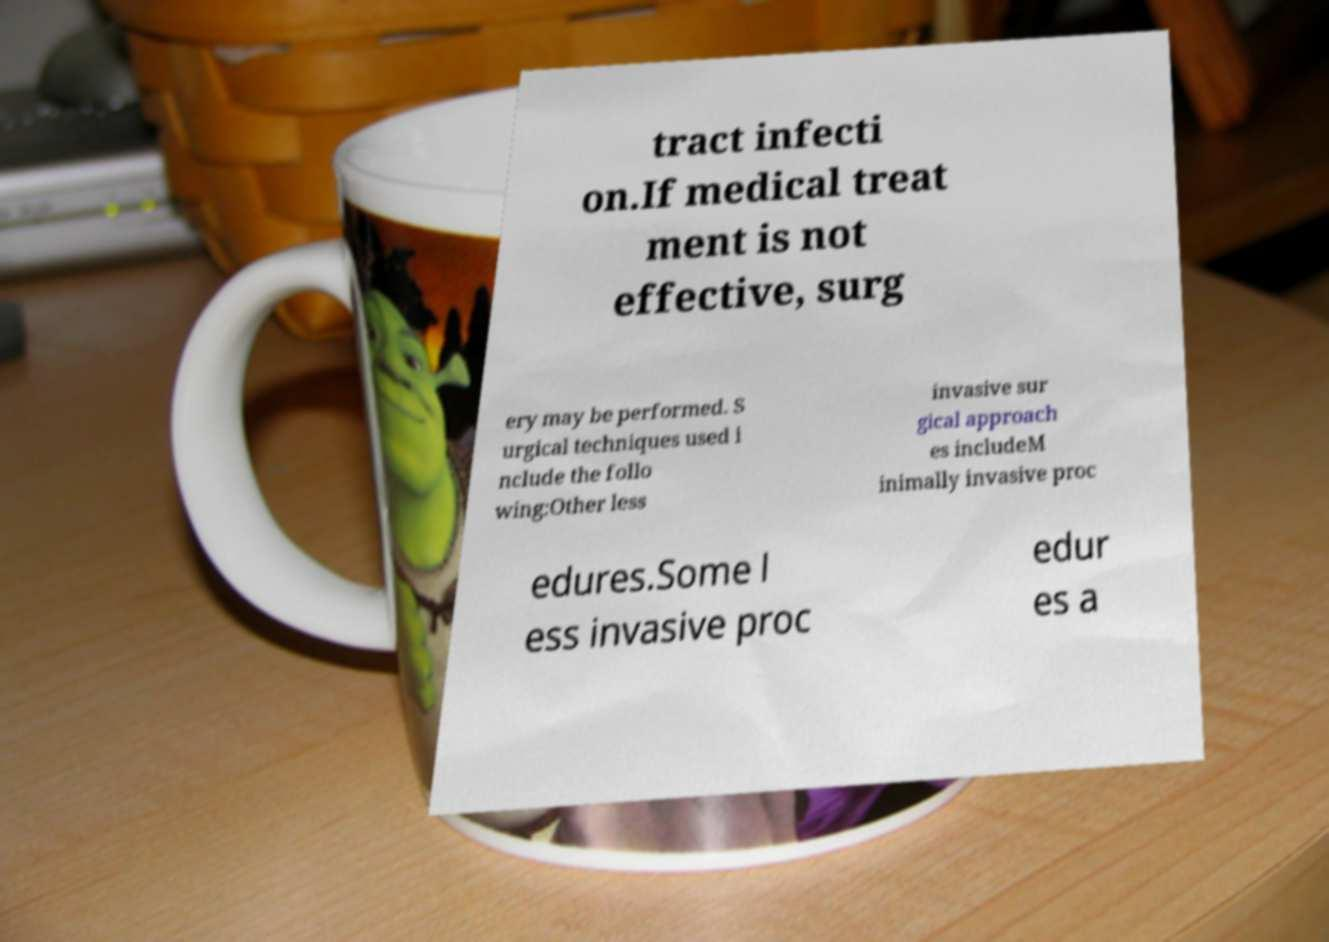Could you extract and type out the text from this image? tract infecti on.If medical treat ment is not effective, surg ery may be performed. S urgical techniques used i nclude the follo wing:Other less invasive sur gical approach es includeM inimally invasive proc edures.Some l ess invasive proc edur es a 